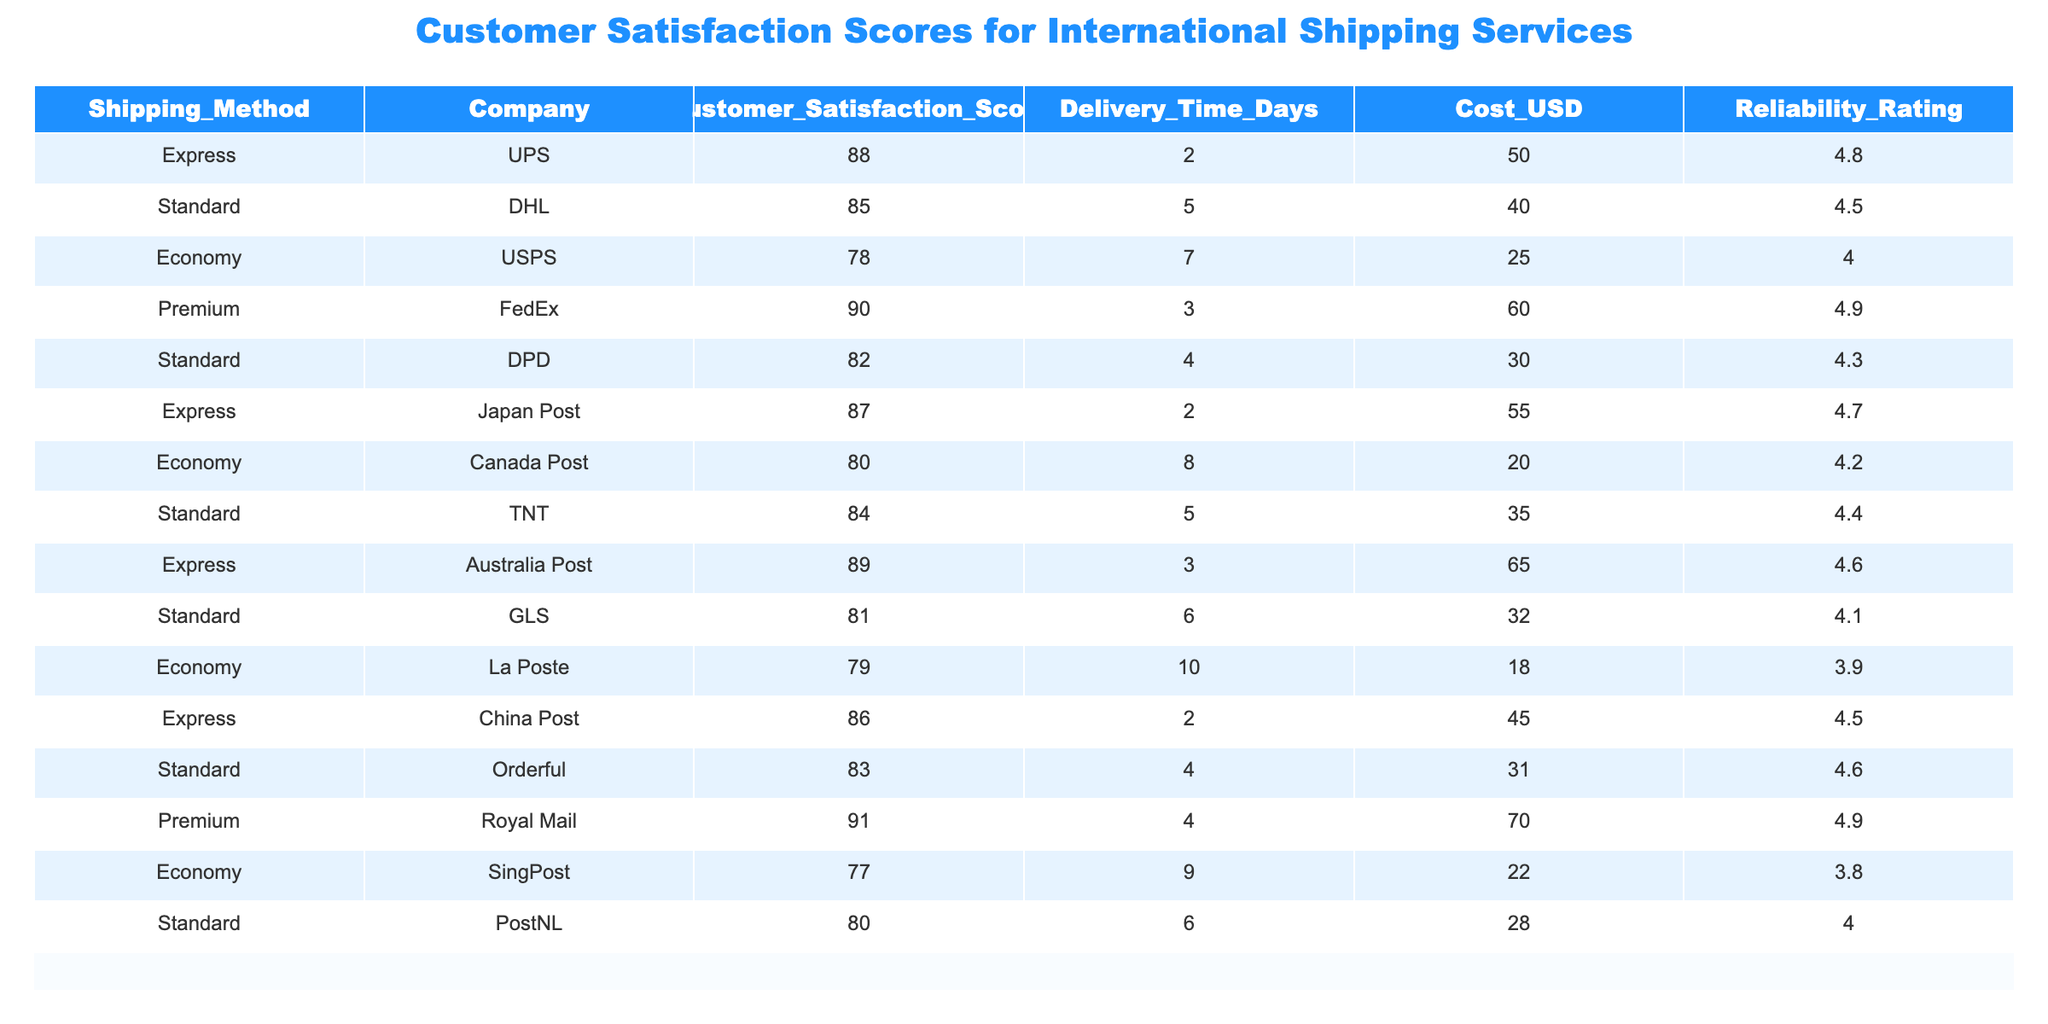What is the customer satisfaction score for FedEx's Premium service? The table shows that the customer satisfaction score for FedEx's Premium service is 90.
Answer: 90 Which shipping method has the highest reliability rating? By examining the reliability ratings in the table, the shipping methods FedEx's Premium and Royal Mail both have the highest reliability rating of 4.9.
Answer: FedEx's Premium and Royal Mail What is the average customer satisfaction score for Economy shipping methods? The customer satisfaction scores for Economy shipping methods are 78 (USPS), 80 (Canada Post), 79 (La Poste), and 77 (SingPost). Adding these scores gives 78 + 80 + 79 + 77 = 314. There are 4 data points, so the average is 314 / 4 = 78.5.
Answer: 78.5 Is the delivery time for the Economy shipping method provided by USPS longer than that of the Express method by China Post? USPS has a delivery time of 7 days for the Economy method, while China Post has a delivery time of 2 days for the Express method. Since 7 is not greater than 2, the statement is false.
Answer: No Which company offers the lowest cost for their Economy shipping method? Canada Post charges 20 USD for their Economy service, which is the lowest when compared to other Economy shipping methods, which range from 22 to 25 USD.
Answer: Canada Post What is the difference in customer satisfaction scores between the Express service of UPS and the Standard service of DHL? The customer satisfaction score for UPS's Express service is 88, and for DHL's Standard service, it is 85. The difference is 88 - 85 = 3.
Answer: 3 How many shipping methods have a customer satisfaction score of 80 or more? The scores that are 80 or more are: 88 (UPS Express), 85 (DHL Standard), 90 (FedEx Premium), 87 (Japan Post Express), 89 (Australia Post Express), 84 (TNT Standard), and 83 (Orderful Standard), and 91 (Royal Mail Premium). Counting these gives 8 methods total.
Answer: 8 Does the Economy shipping method provided by SingPost have a higher customer satisfaction score than the Standard service from GLS? SingPost's Economy service has a score of 77 while GLS's Standard service has a score of 81. Since 77 is not higher than 81, the statement is false.
Answer: No Which shipping method provides the fastest delivery time along with its respective company? The fastest delivery time listed is 2 days, provided by Express services from UPS and China Post.
Answer: UPS and China Post 